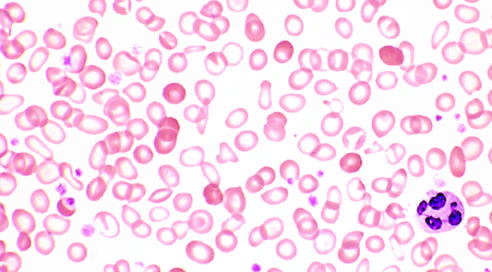do the principal cellular alterations that characterize reversible cell injury and necrosis stand out in contrast?
Answer the question using a single word or phrase. No 